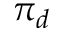<formula> <loc_0><loc_0><loc_500><loc_500>\pi _ { d }</formula> 